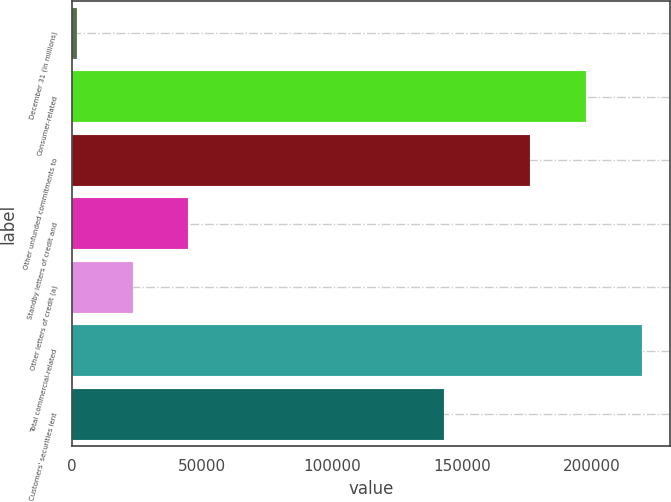Convert chart. <chart><loc_0><loc_0><loc_500><loc_500><bar_chart><fcel>December 31 (in millions)<fcel>Consumer-related<fcel>Other unfunded commitments to<fcel>Standby letters of credit and<fcel>Other letters of credit (a)<fcel>Total commercial-related<fcel>Customers' securities lent<nl><fcel>2003<fcel>197598<fcel>176222<fcel>44754<fcel>23378.5<fcel>218973<fcel>143143<nl></chart> 